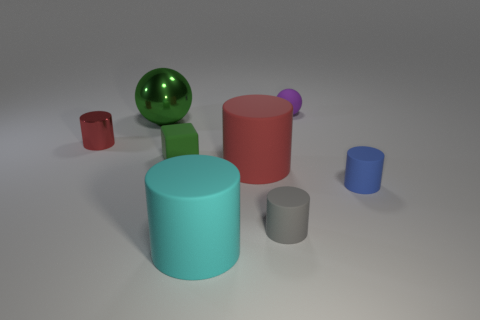Subtract all small red metal cylinders. How many cylinders are left? 4 Add 2 purple objects. How many objects exist? 10 Subtract all green balls. How many balls are left? 1 Subtract all cylinders. How many objects are left? 3 Subtract 1 cylinders. How many cylinders are left? 4 Add 4 small purple matte balls. How many small purple matte balls exist? 5 Subtract 0 purple blocks. How many objects are left? 8 Subtract all purple spheres. Subtract all purple blocks. How many spheres are left? 1 Subtract all brown balls. How many cyan cylinders are left? 1 Subtract all matte blocks. Subtract all tiny things. How many objects are left? 2 